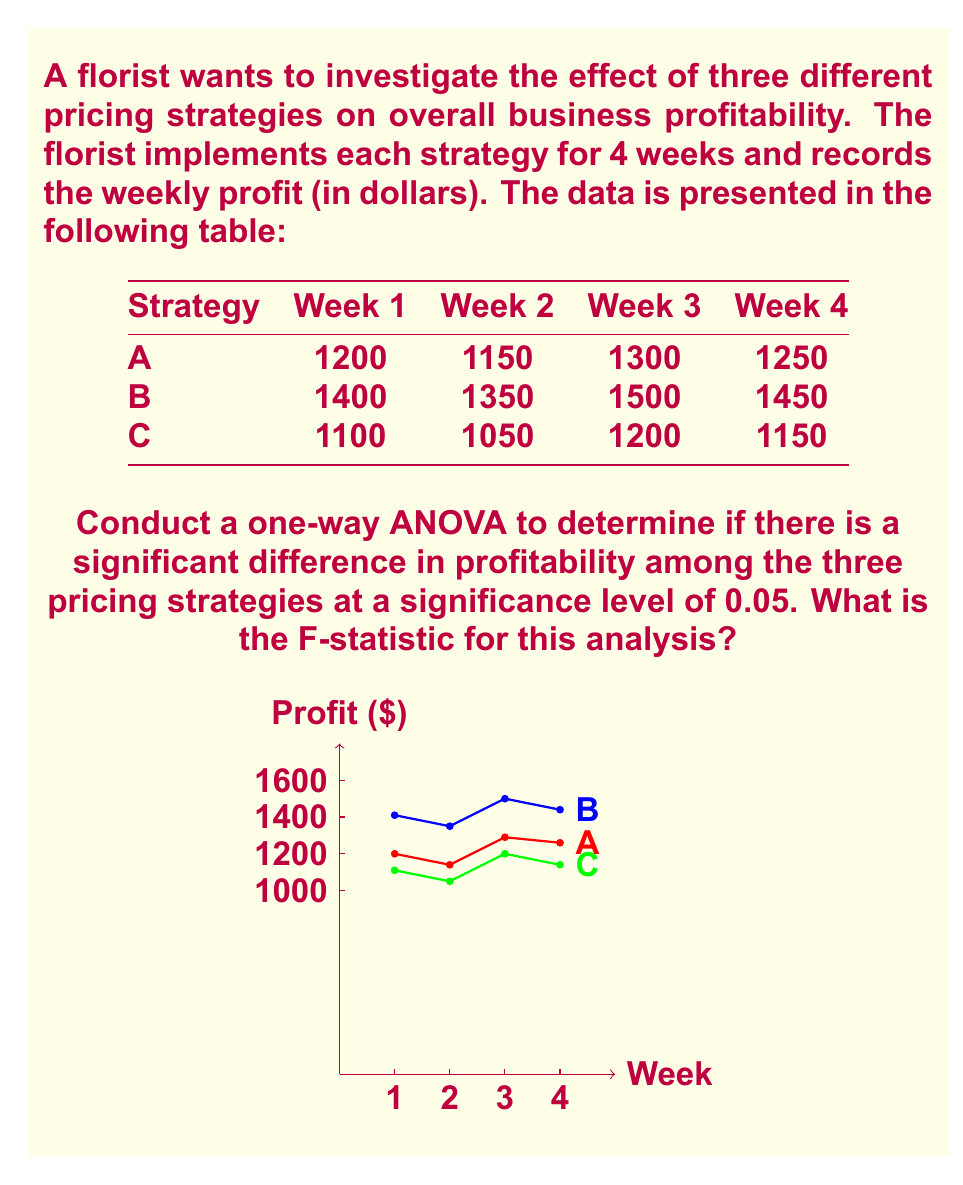Could you help me with this problem? To conduct a one-way ANOVA, we need to follow these steps:

1) Calculate the mean for each group (pricing strategy):
   Strategy A: $\bar{X}_A = \frac{1200 + 1150 + 1300 + 1250}{4} = 1225$
   Strategy B: $\bar{X}_B = \frac{1400 + 1350 + 1500 + 1450}{4} = 1425$
   Strategy C: $\bar{X}_C = \frac{1100 + 1050 + 1200 + 1150}{4} = 1125$

2) Calculate the grand mean:
   $\bar{X} = \frac{1225 + 1425 + 1125}{3} = 1258.33$

3) Calculate the Sum of Squares Between (SSB):
   $SSB = 4[(1225 - 1258.33)^2 + (1425 - 1258.33)^2 + (1125 - 1258.33)^2] = 180,000$

4) Calculate the Sum of Squares Within (SSW):
   $SSW = [(1200 - 1225)^2 + (1150 - 1225)^2 + (1300 - 1225)^2 + (1250 - 1225)^2] + 
          [(1400 - 1425)^2 + (1350 - 1425)^2 + (1500 - 1425)^2 + (1450 - 1425)^2] +
          [(1100 - 1125)^2 + (1050 - 1125)^2 + (1200 - 1125)^2 + (1150 - 1125)^2]
        = 15,000 + 15,000 + 15,000 = 45,000$

5) Calculate the degrees of freedom:
   $df_{between} = 3 - 1 = 2$
   $df_{within} = 3(4 - 1) = 9$

6) Calculate the Mean Square Between (MSB) and Mean Square Within (MSW):
   $MSB = \frac{SSB}{df_{between}} = \frac{180,000}{2} = 90,000$
   $MSW = \frac{SSW}{df_{within}} = \frac{45,000}{9} = 5,000$

7) Calculate the F-statistic:
   $F = \frac{MSB}{MSW} = \frac{90,000}{5,000} = 18$

The F-statistic for this analysis is 18.
Answer: 18 